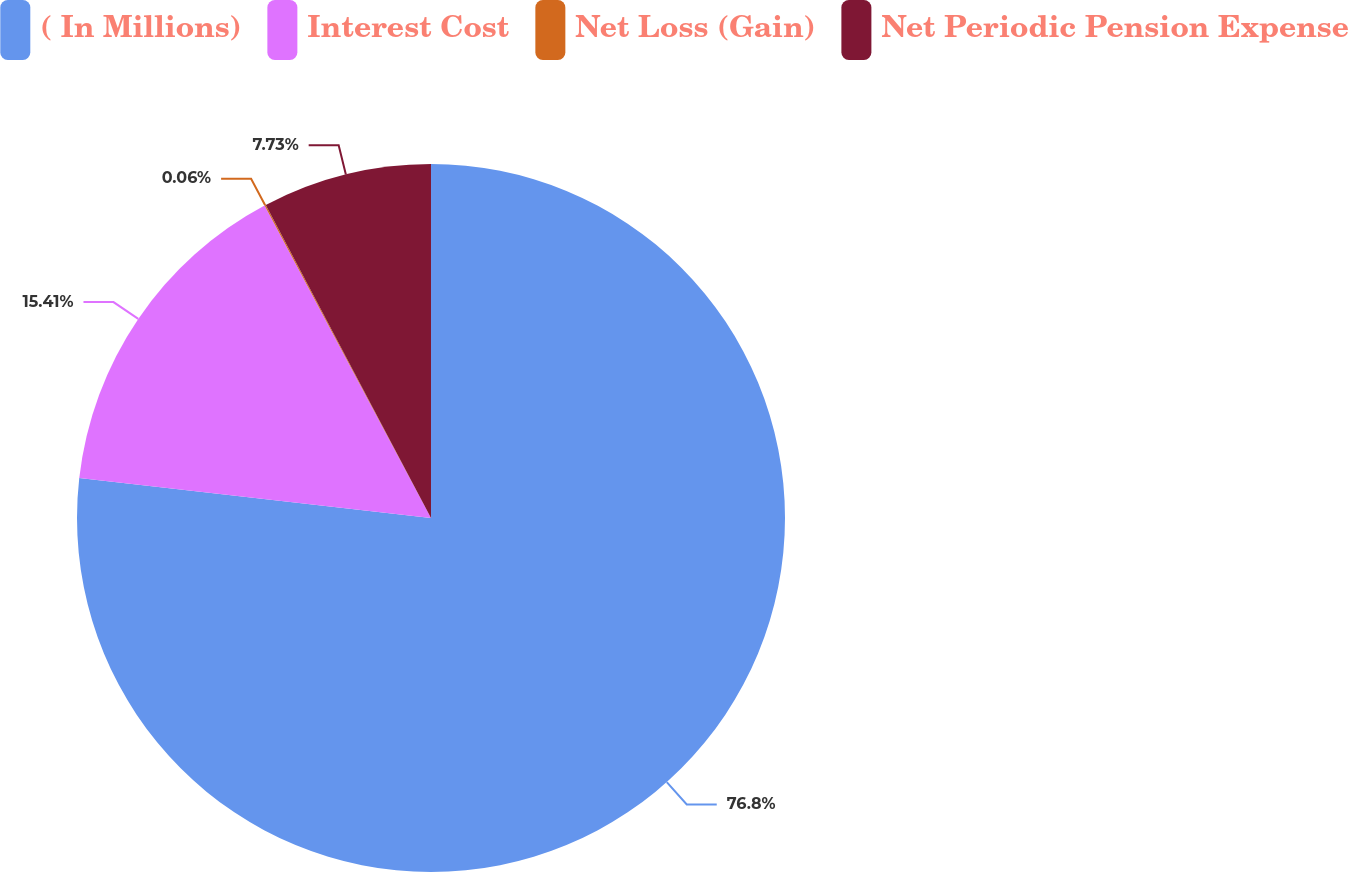Convert chart to OTSL. <chart><loc_0><loc_0><loc_500><loc_500><pie_chart><fcel>( In Millions)<fcel>Interest Cost<fcel>Net Loss (Gain)<fcel>Net Periodic Pension Expense<nl><fcel>76.8%<fcel>15.41%<fcel>0.06%<fcel>7.73%<nl></chart> 